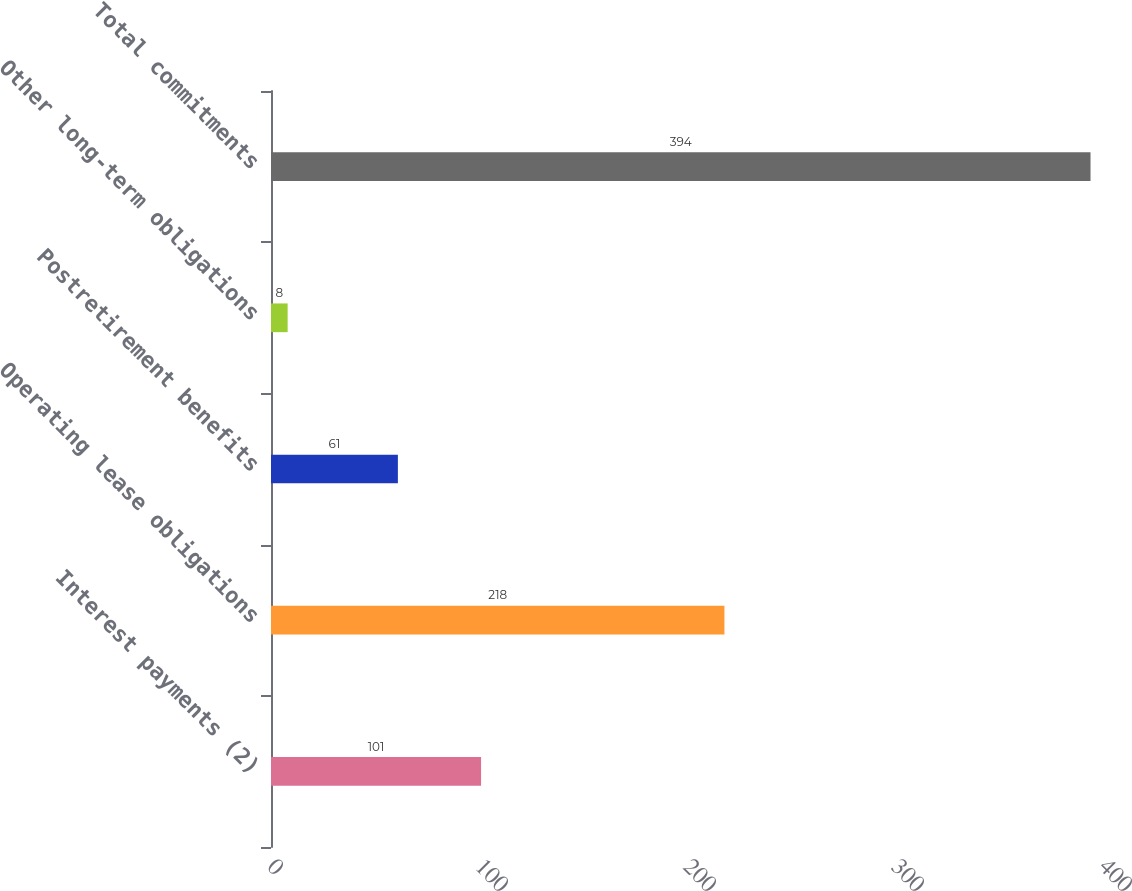Convert chart. <chart><loc_0><loc_0><loc_500><loc_500><bar_chart><fcel>Interest payments (2)<fcel>Operating lease obligations<fcel>Postretirement benefits<fcel>Other long-term obligations<fcel>Total commitments<nl><fcel>101<fcel>218<fcel>61<fcel>8<fcel>394<nl></chart> 